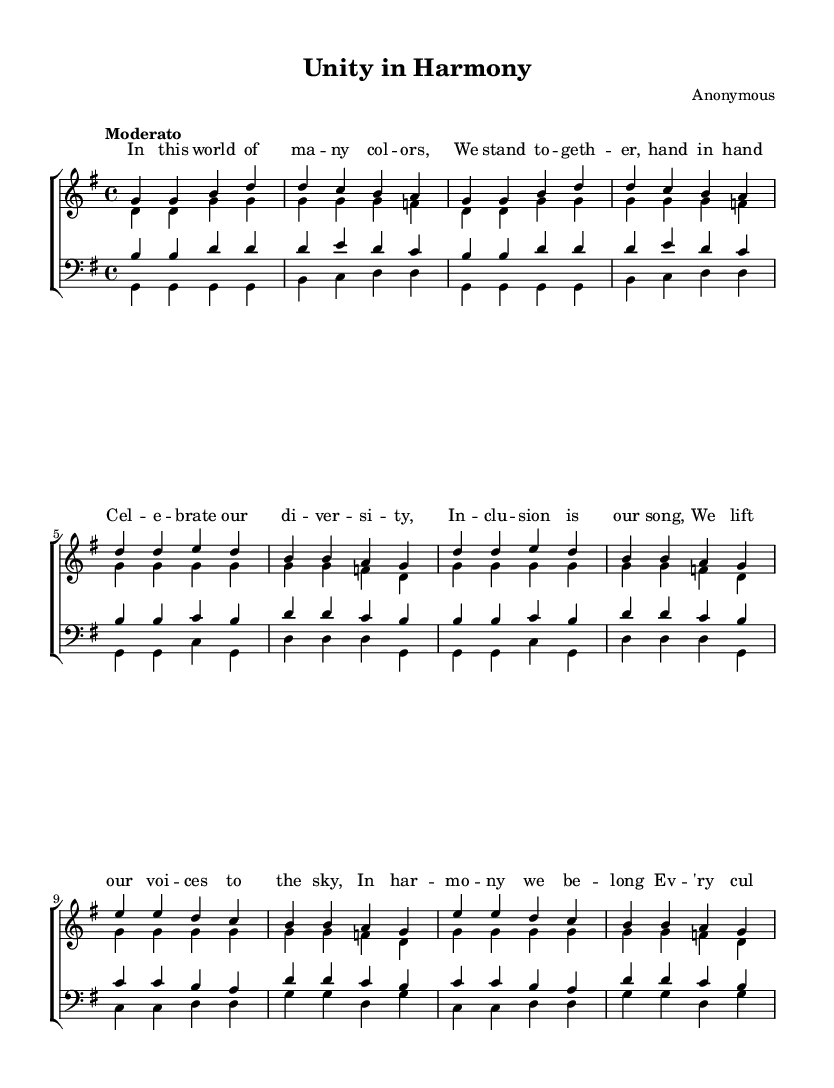What is the key signature of this music? The key signature indicated at the beginning of the score is G major, which has one sharp (F#).
Answer: G major What is the time signature of this composition? The time signature seen in the score is 4/4, meaning there are four beats in each measure and the quarter note gets one beat.
Answer: 4/4 What is the tempo marking for this piece? The tempo marking is "Moderato," indicating a moderate speed for the performance of this piece.
Answer: Moderato How many verses are there in this music? The score includes one verse section for each vocal part (soprano, alto, tenor, bass), so there are four verses in total, one for each voice type.
Answer: 4 During the chorus, what is the main theme of the lyrics? The lyrics of the chorus celebrate diversity and inclusion, emphasizing harmony and belonging. This can be seen in the repeated phrase, "Celebrate our diversity."
Answer: Celebrate our diversity What vocal parts are included in this piece? The composition includes four vocal parts: sopranos, altos, tenors, and basses, which are standard for choir arrangements.
Answer: Sopranos, altos, tenors, basses What cultural aspect is highlighted in the bridge lyrics? The bridge lyrics emphasize every culture and background, illustrating a tapestry woven from diversity, which reflects the central theme of inclusion.
Answer: Every culture, every background 